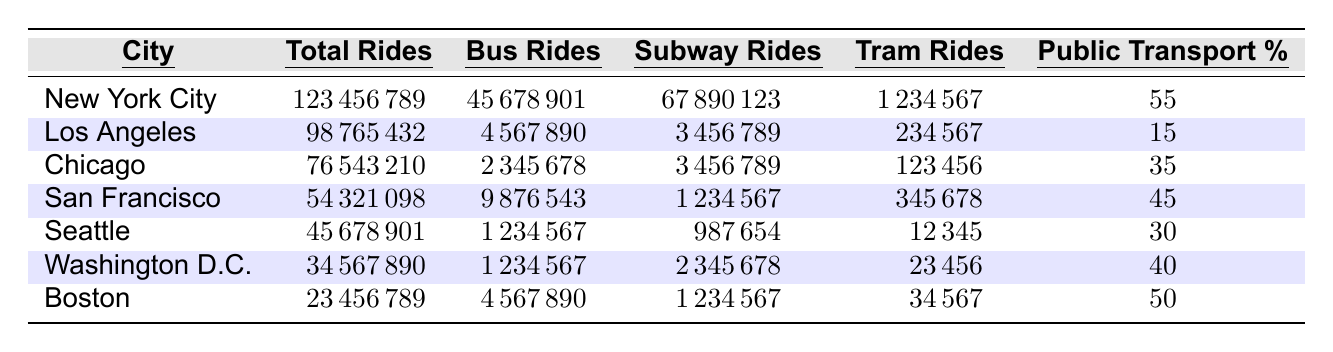What city has the highest total rides? New York City has the highest total rides with 123,456,789.
Answer: New York City What is the total number of tram rides in Chicago? Chicago has a total of 123,456 tram rides listed in the data.
Answer: 123,456 What percentage of public transport usage is reported for Los Angeles? Los Angeles has a public transport percentage of 15%.
Answer: 15% Which city has the second highest number of subway rides? San Francisco has the second highest subway rides with 1,234,567, following New York City.
Answer: San Francisco What is the difference in total rides between San Francisco and Seattle? San Francisco has 54,321,098 total rides and Seattle has 45,678,901. The difference is 54,321,098 - 45,678,901 = 8,642,197.
Answer: 8,642,197 Is Boston's public transport percentage higher than Chicago's? Yes, Boston has a public transport percentage of 50%, while Chicago has 35%.
Answer: Yes What is the average public transport percentage for the listed cities? To find the average, sum up the percentages: (55 + 15 + 35 + 45 + 30 + 40 + 50) = 270. Divide by 7 (the number of cities): 270 / 7 = 38.57, approximately.
Answer: 38.57 How many more bus rides did New York City have compared to Washington D.C.? New York City had 45,678,901 bus rides while Washington D.C. had 1,234,567. The difference is 45,678,901 - 1,234,567 = 44,444,334.
Answer: 44,444,334 Which city has the lowest percentage of public transport usage? Los Angeles has the lowest percentage of public transport usage at 15%.
Answer: Los Angeles What is the total number of rides for all cities combined? The combined total rides can be calculated by summing all totals: 123,456,789 + 98,765,432 + 76,543,210 + 54,321,098 + 45,678,901 + 34,567,890 + 23,456,789 = 456,567,109.
Answer: 456,567,109 How does the total subway rides in Seattle compare to that of Chicago? Seattle has 987,654 subway rides while Chicago has 3,456,789. Since 987,654 is less than 3,456,789, Seattle has fewer subway rides.
Answer: Fewer rides in Seattle 